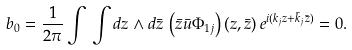Convert formula to latex. <formula><loc_0><loc_0><loc_500><loc_500>b _ { 0 } = \frac { 1 } { 2 \pi } \int \, \int d z \wedge d \bar { z } \, \left ( \bar { z } \bar { u } \Phi _ { 1 j } \right ) ( z , \bar { z } ) \, e ^ { i ( k _ { j } z + \bar { k } _ { j } \bar { z } ) } = 0 .</formula> 